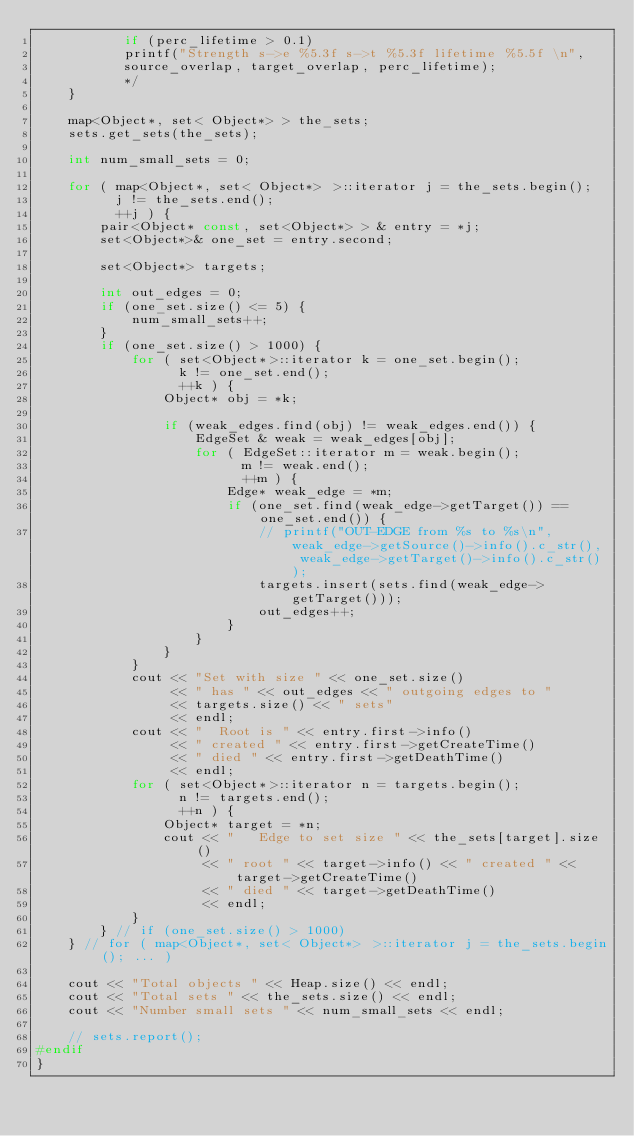Convert code to text. <code><loc_0><loc_0><loc_500><loc_500><_C++_>           if (perc_lifetime > 0.1)
           printf("Strength s->e %5.3f s->t %5.3f lifetime %5.5f \n",
           source_overlap, target_overlap, perc_lifetime);
           */
    }

    map<Object*, set< Object*> > the_sets;
    sets.get_sets(the_sets);

    int num_small_sets = 0;

    for ( map<Object*, set< Object*> >::iterator j = the_sets.begin();
          j != the_sets.end();
          ++j ) {
        pair<Object* const, set<Object*> > & entry = *j;
        set<Object*>& one_set = entry.second;

        set<Object*> targets;

        int out_edges = 0;
        if (one_set.size() <= 5) {
            num_small_sets++;
        }
        if (one_set.size() > 1000) {
            for ( set<Object*>::iterator k = one_set.begin();
                  k != one_set.end();
                  ++k ) {
                Object* obj = *k;

                if (weak_edges.find(obj) != weak_edges.end()) {
                    EdgeSet & weak = weak_edges[obj];
                    for ( EdgeSet::iterator m = weak.begin();
                          m != weak.end();
                          ++m ) {
                        Edge* weak_edge = *m;
                        if (one_set.find(weak_edge->getTarget()) == one_set.end()) {
                            // printf("OUT-EDGE from %s to %s\n", weak_edge->getSource()->info().c_str(), weak_edge->getTarget()->info().c_str());
                            targets.insert(sets.find(weak_edge->getTarget()));
                            out_edges++;
                        }
                    }
                }
            }
            cout << "Set with size " << one_set.size()
                 << " has " << out_edges << " outgoing edges to "
                 << targets.size() << " sets"
                 << endl;
            cout << "  Root is " << entry.first->info()
                 << " created " << entry.first->getCreateTime()
                 << " died " << entry.first->getDeathTime()
                 << endl;
            for ( set<Object*>::iterator n = targets.begin();
                  n != targets.end();
                  ++n ) {
                Object* target = *n;
                cout << "   Edge to set size " << the_sets[target].size()
                     << " root " << target->info() << " created " << target->getCreateTime()
                     << " died " << target->getDeathTime()
                     << endl;
            }
        } // if (one_set.size() > 1000)
    } // for ( map<Object*, set< Object*> >::iterator j = the_sets.begin(); ... )

    cout << "Total objects " << Heap.size() << endl;
    cout << "Total sets " << the_sets.size() << endl;
    cout << "Number small sets " << num_small_sets << endl;

    // sets.report();
#endif
}
</code> 